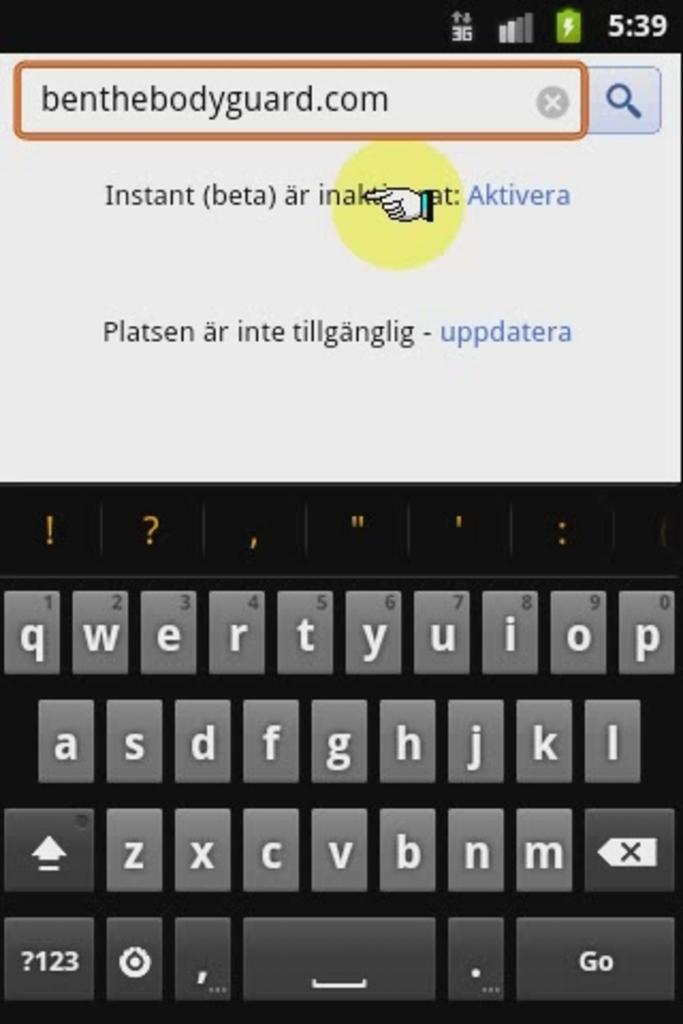<image>
Write a terse but informative summary of the picture. a phone screen navigated to benthebodyguard.com which has two links 